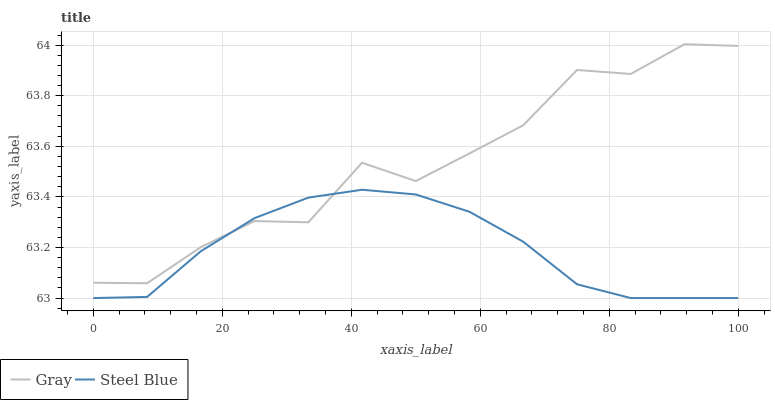Does Steel Blue have the minimum area under the curve?
Answer yes or no. Yes. Does Gray have the maximum area under the curve?
Answer yes or no. Yes. Does Steel Blue have the maximum area under the curve?
Answer yes or no. No. Is Steel Blue the smoothest?
Answer yes or no. Yes. Is Gray the roughest?
Answer yes or no. Yes. Is Steel Blue the roughest?
Answer yes or no. No. Does Gray have the highest value?
Answer yes or no. Yes. Does Steel Blue have the highest value?
Answer yes or no. No. Does Gray intersect Steel Blue?
Answer yes or no. Yes. Is Gray less than Steel Blue?
Answer yes or no. No. Is Gray greater than Steel Blue?
Answer yes or no. No. 